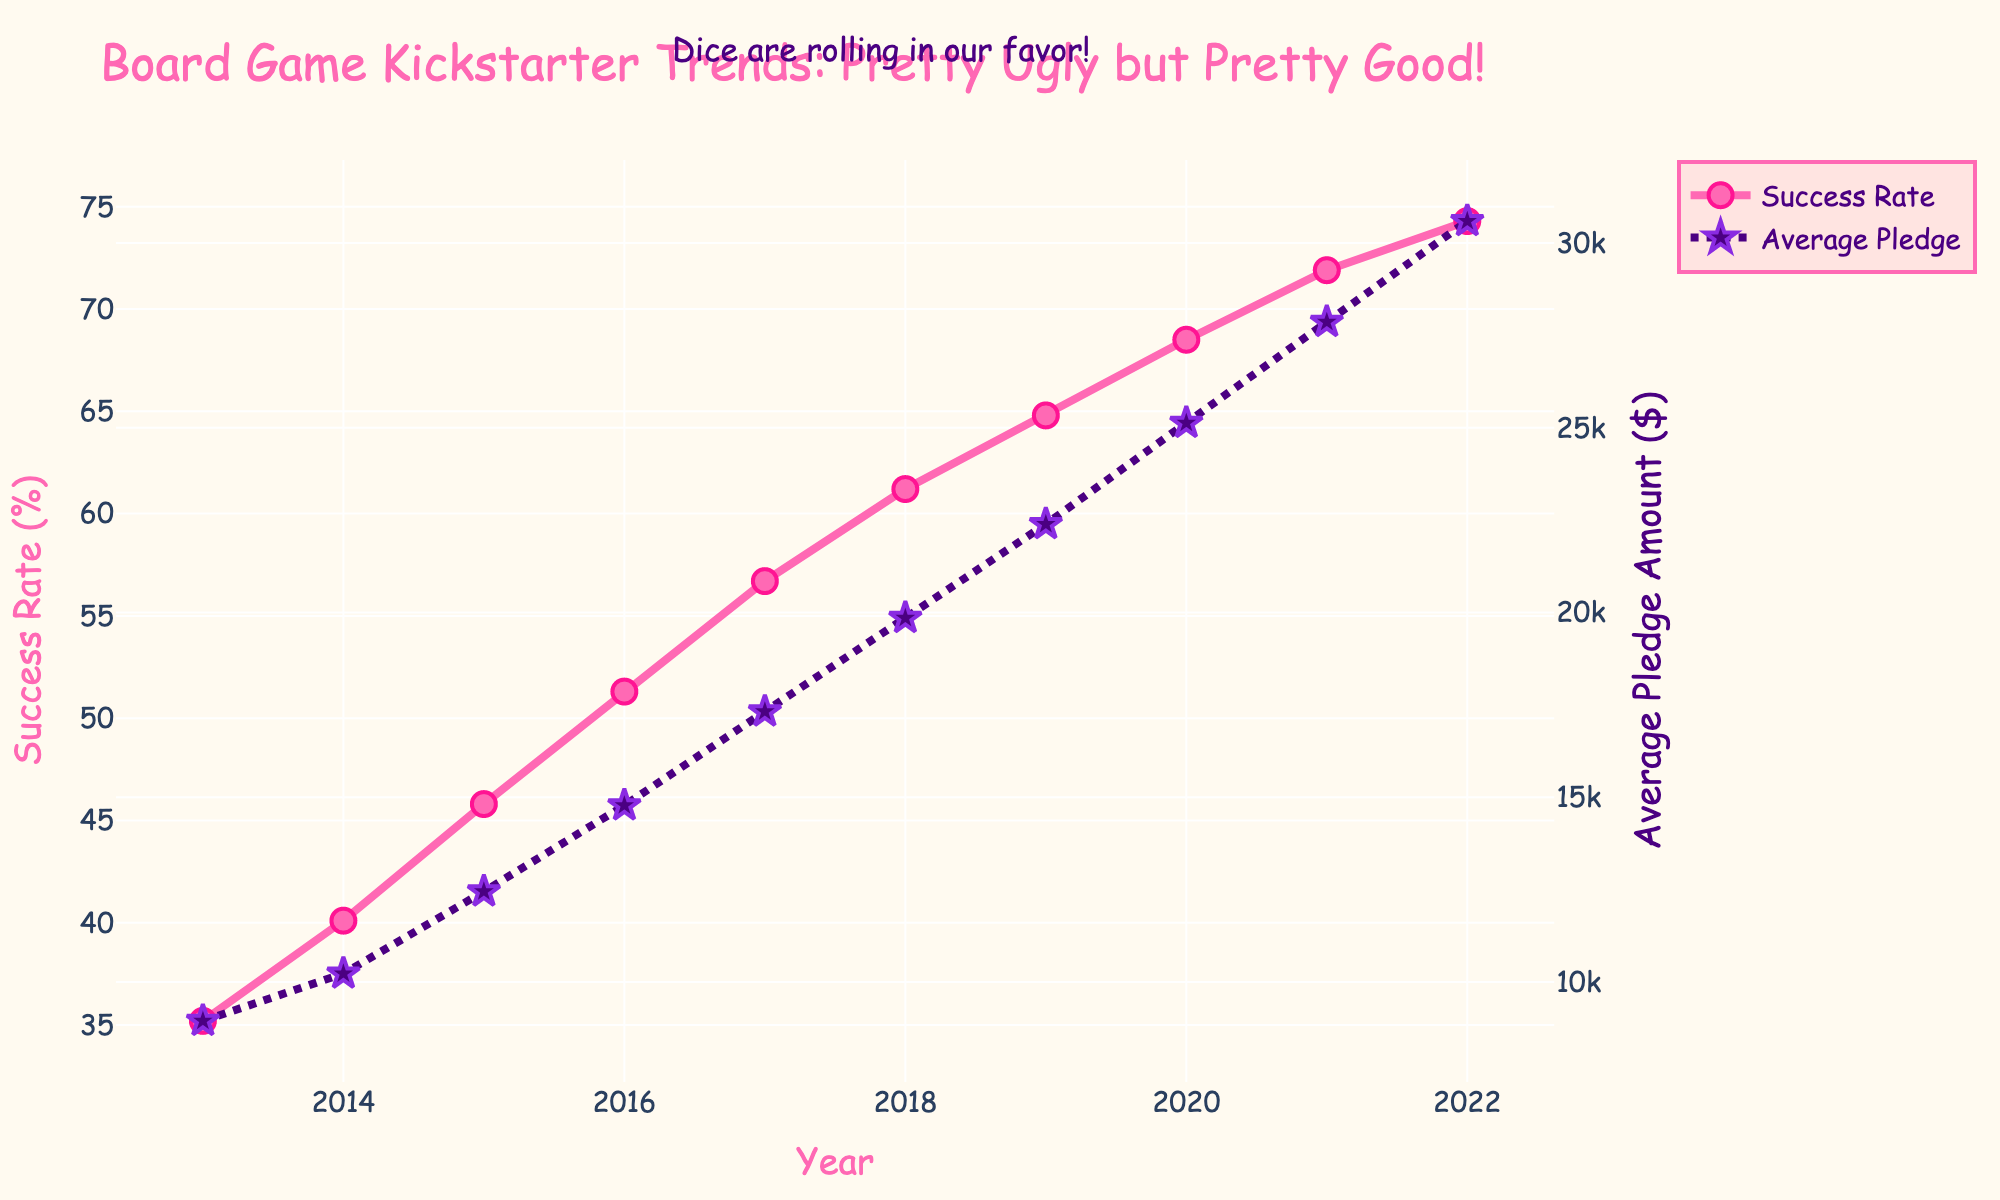What's the trend in the success rate over the years? The success rate has shown a steady increase from 35.2% in 2013 to 74.3% in 2022, as indicated by the upward progression of the pink line with circle markers.
Answer: Increasing What is the average pledge amount in 2017? Locate the purple dotted line with star markers at the 2017 tick mark on the x-axis; the value aligns to approximately $17,320.
Answer: $17,320 By how much has the average pledge amount increased from 2015 to 2020? Subtract the average pledge amount in 2015 ($12,450) from that in 2020 ($25,130); 25,130 - 12,450 = 12,680.
Answer: $12,680 Which year saw the highest increase in success rate compared to the previous year? By calculating the differences per year: 2014-2013 (40.1-35.2=4.9), 2015-2014 (45.8-40.1=5.7), 2016-2015 (51.3-45.8=5.5), 2017-2016 (56.7-51.3=5.4), 2018-2017 (61.2-56.7=4.5), 2019-2018 (64.8-61.2=3.6), 2020-2019 (68.5-64.8=3.7), 2021-2020 (71.9-68.5=3.4), 2022-2021 (74.3-71.9=2.4); the highest increase is from 2014 to 2015, which is 5.7%.
Answer: 2015 What was the success rate and average pledge amount in the year with the lowest success rate? In 2013, the success rate was the lowest at 35.2%, and the corresponding average pledge amount was $8,950.
Answer: 35.2% and $8,950 How does the success rate change from the year that marked a 50% success rate? In 2016, the success rate was 51.3%. Comparing it to the previous year (45.8% in 2015), it increased by 5.5%, and in subsequent years, it further increased by following annual increments till 2022.
Answer: Increased Which visual element indicates the average pledge amount? The purple dotted line with star markers indicates the average pledge amount.
Answer: Purple dotted line with stars Compare the rise in average pledge amount between 2018 to 2019 and 2021 to 2022. Which period has a higher rise? Calculate the difference between average pledge amounts for the periods: 2019-2018 (22,390 - 19,850 = 2,540), and 2022-2021 (30,590 - 27,860 = 2,730); 2021 to 2022 has a higher rise.
Answer: 2021 to 2022 What annotations or comments are included in the chart? The chart includes an annotation positioned slightly above center, stating "Dice are rolling in our favor!"
Answer: Dice are rolling in our favor! 